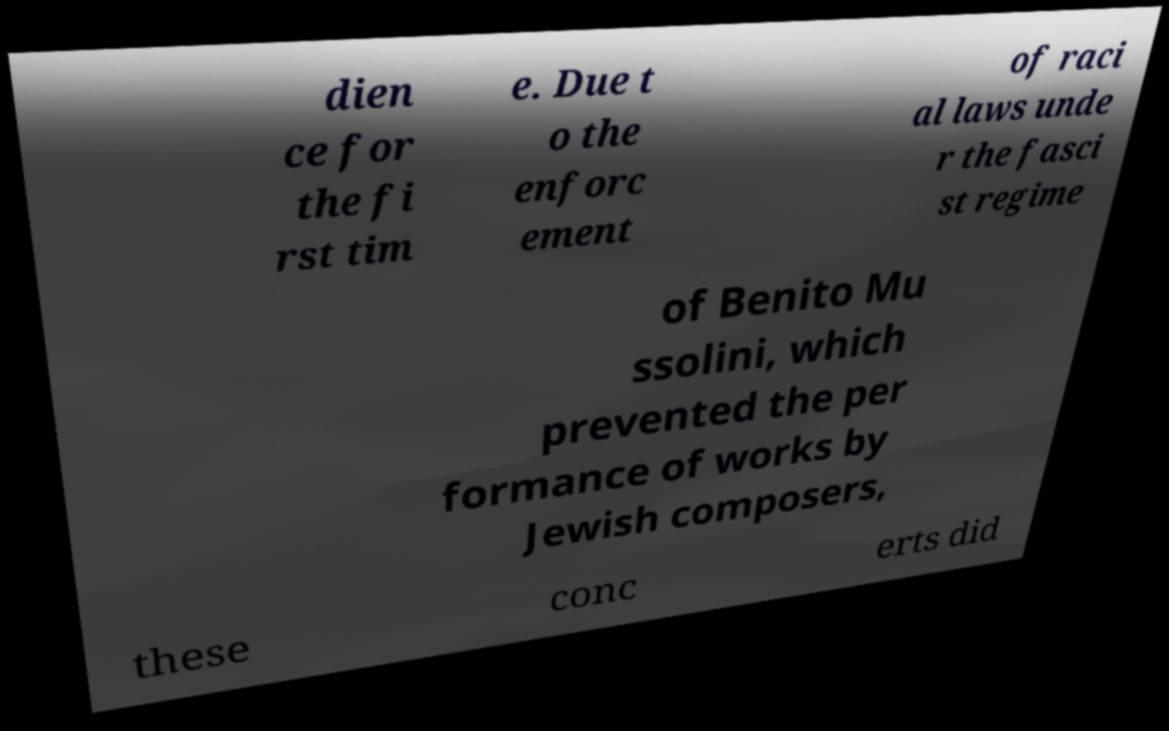Can you accurately transcribe the text from the provided image for me? dien ce for the fi rst tim e. Due t o the enforc ement of raci al laws unde r the fasci st regime of Benito Mu ssolini, which prevented the per formance of works by Jewish composers, these conc erts did 